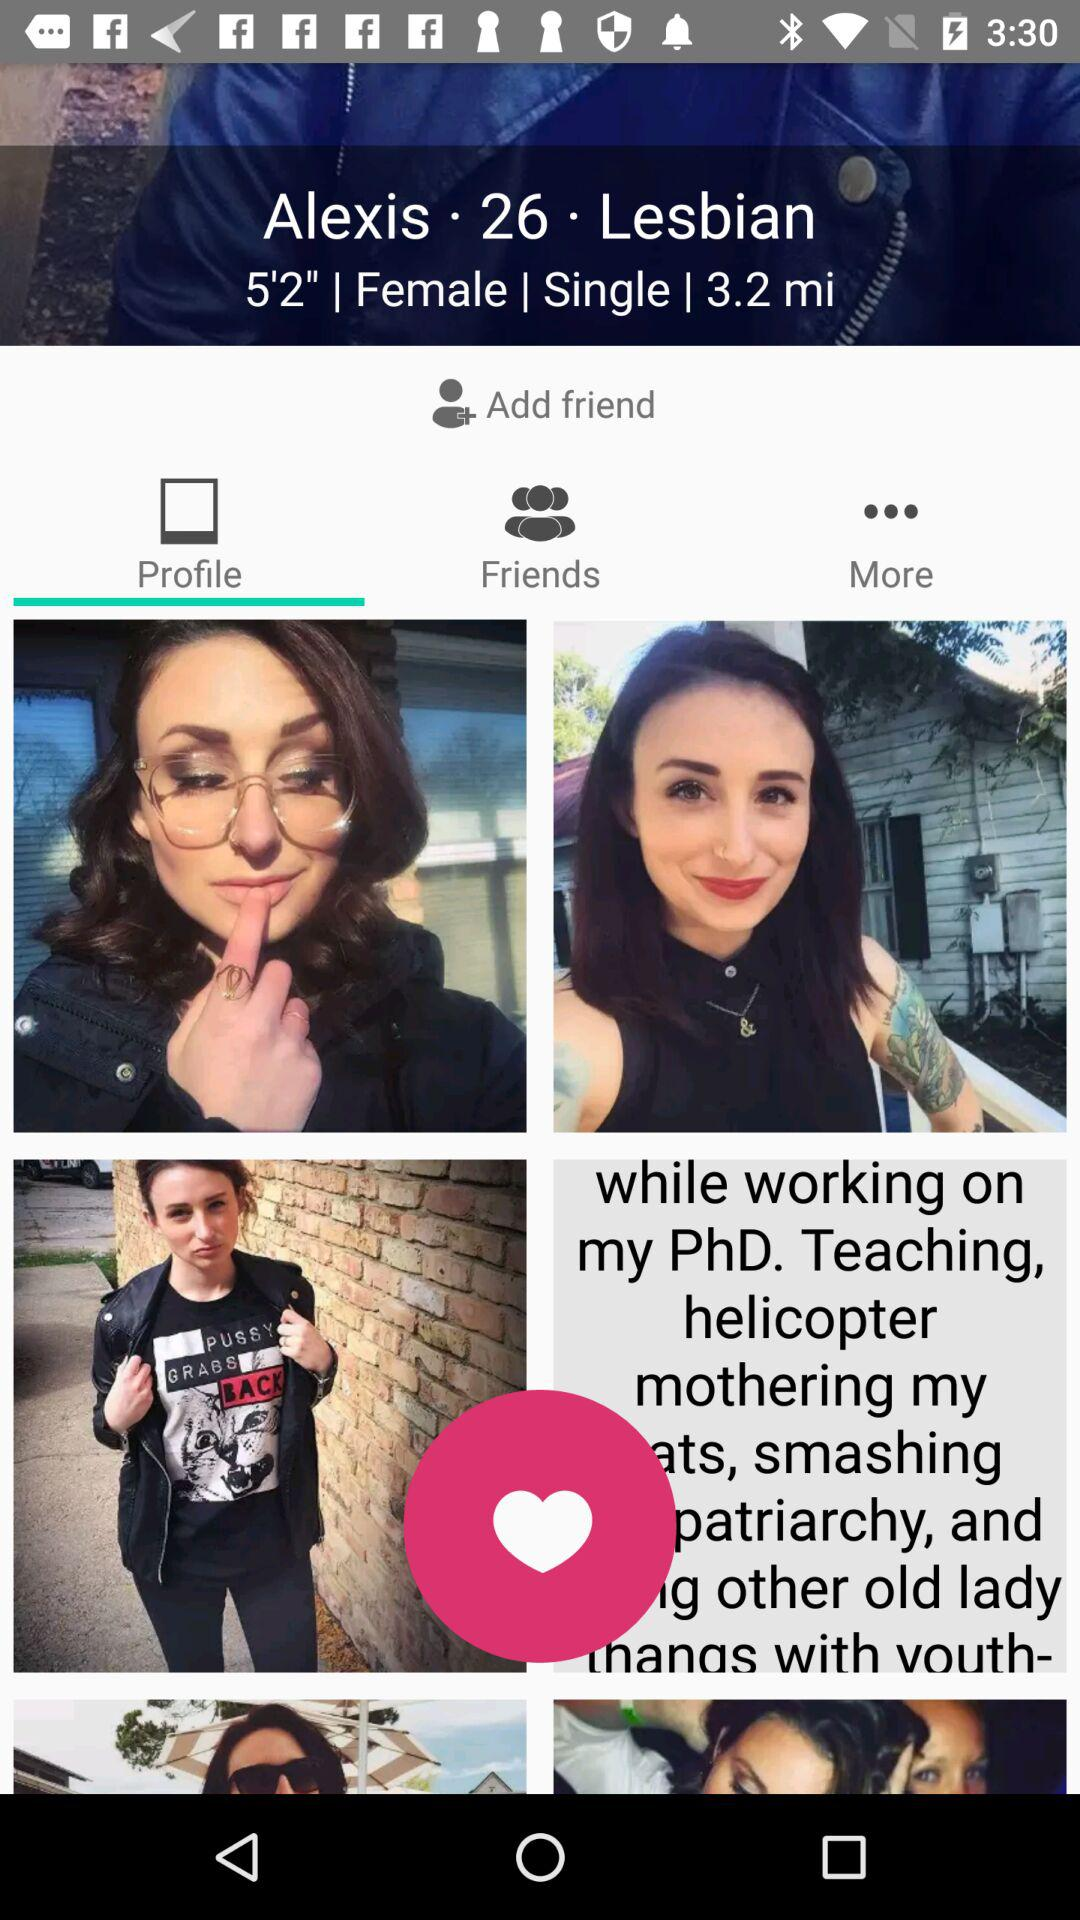How tall is the user? The user is 5'2" tall. 